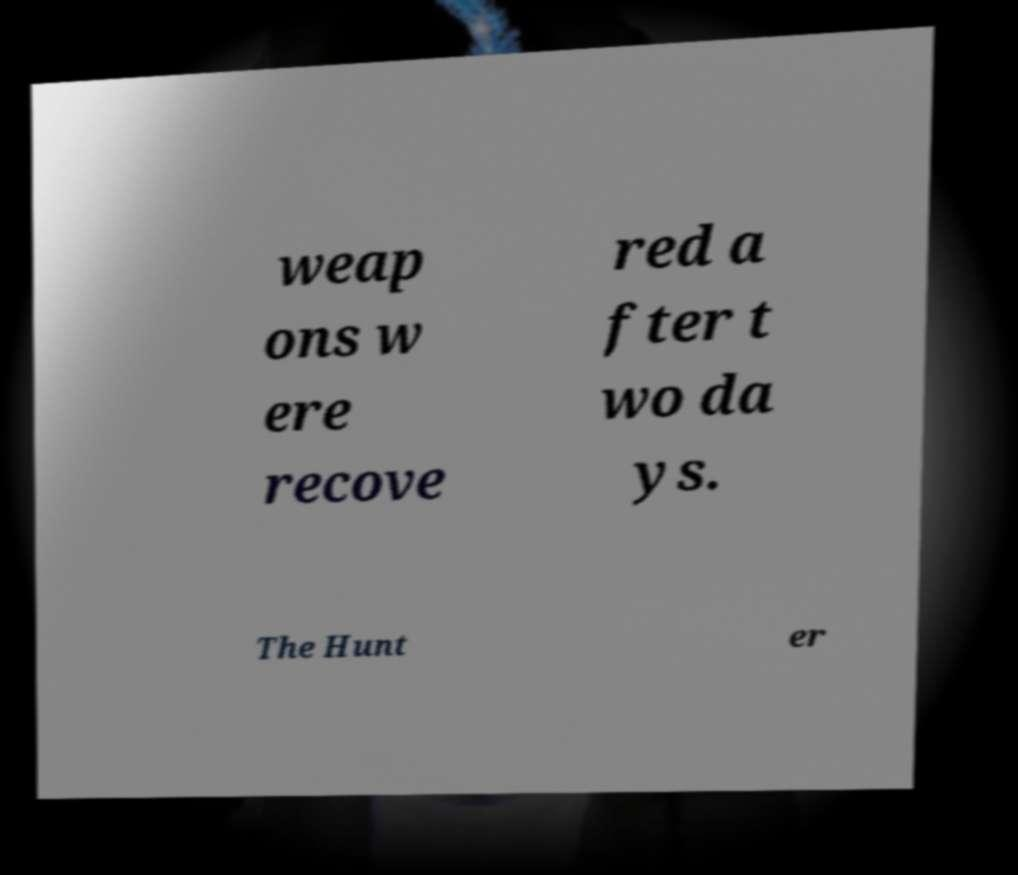What messages or text are displayed in this image? I need them in a readable, typed format. weap ons w ere recove red a fter t wo da ys. The Hunt er 